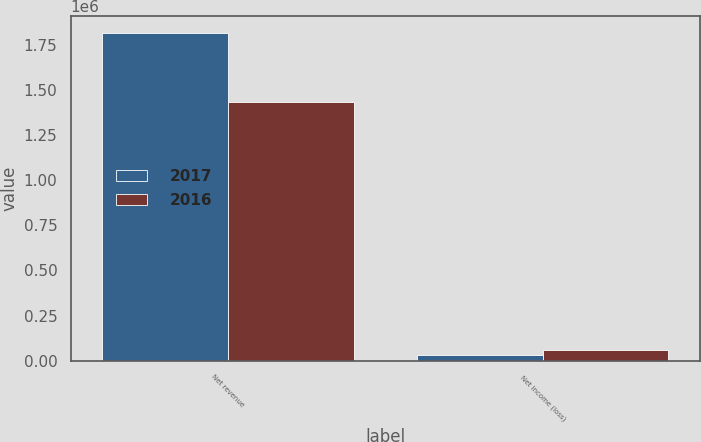<chart> <loc_0><loc_0><loc_500><loc_500><stacked_bar_chart><ecel><fcel>Net revenue<fcel>Net income (loss)<nl><fcel>2017<fcel>1.81523e+06<fcel>30161<nl><fcel>2016<fcel>1.42963e+06<fcel>61805<nl></chart> 